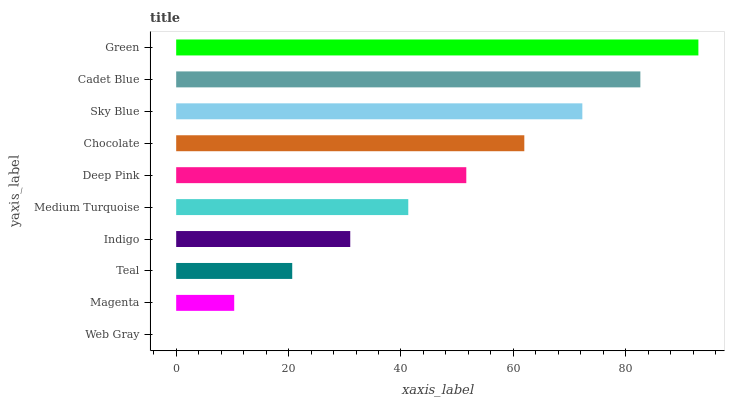Is Web Gray the minimum?
Answer yes or no. Yes. Is Green the maximum?
Answer yes or no. Yes. Is Magenta the minimum?
Answer yes or no. No. Is Magenta the maximum?
Answer yes or no. No. Is Magenta greater than Web Gray?
Answer yes or no. Yes. Is Web Gray less than Magenta?
Answer yes or no. Yes. Is Web Gray greater than Magenta?
Answer yes or no. No. Is Magenta less than Web Gray?
Answer yes or no. No. Is Deep Pink the high median?
Answer yes or no. Yes. Is Medium Turquoise the low median?
Answer yes or no. Yes. Is Teal the high median?
Answer yes or no. No. Is Indigo the low median?
Answer yes or no. No. 